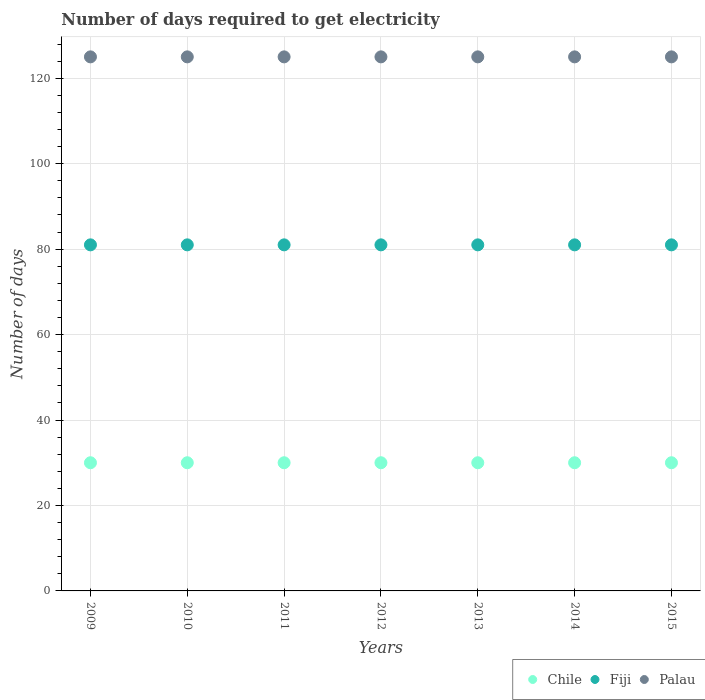Is the number of dotlines equal to the number of legend labels?
Make the answer very short. Yes. What is the number of days required to get electricity in in Palau in 2009?
Ensure brevity in your answer.  125. Across all years, what is the maximum number of days required to get electricity in in Chile?
Provide a succinct answer. 30. Across all years, what is the minimum number of days required to get electricity in in Chile?
Provide a succinct answer. 30. In which year was the number of days required to get electricity in in Fiji maximum?
Provide a succinct answer. 2009. In which year was the number of days required to get electricity in in Chile minimum?
Your answer should be compact. 2009. What is the total number of days required to get electricity in in Fiji in the graph?
Your answer should be very brief. 567. What is the difference between the number of days required to get electricity in in Fiji in 2013 and the number of days required to get electricity in in Chile in 2014?
Make the answer very short. 51. In the year 2015, what is the difference between the number of days required to get electricity in in Fiji and number of days required to get electricity in in Palau?
Ensure brevity in your answer.  -44. In how many years, is the number of days required to get electricity in in Fiji greater than 120 days?
Make the answer very short. 0. What is the ratio of the number of days required to get electricity in in Chile in 2011 to that in 2012?
Ensure brevity in your answer.  1. Is the number of days required to get electricity in in Chile in 2013 less than that in 2014?
Provide a short and direct response. No. Is the sum of the number of days required to get electricity in in Chile in 2011 and 2012 greater than the maximum number of days required to get electricity in in Fiji across all years?
Your response must be concise. No. Is it the case that in every year, the sum of the number of days required to get electricity in in Chile and number of days required to get electricity in in Palau  is greater than the number of days required to get electricity in in Fiji?
Give a very brief answer. Yes. Does the number of days required to get electricity in in Fiji monotonically increase over the years?
Make the answer very short. No. How many dotlines are there?
Make the answer very short. 3. What is the difference between two consecutive major ticks on the Y-axis?
Your response must be concise. 20. Are the values on the major ticks of Y-axis written in scientific E-notation?
Your answer should be compact. No. Does the graph contain any zero values?
Your answer should be compact. No. Does the graph contain grids?
Give a very brief answer. Yes. How are the legend labels stacked?
Provide a succinct answer. Horizontal. What is the title of the graph?
Keep it short and to the point. Number of days required to get electricity. What is the label or title of the Y-axis?
Offer a terse response. Number of days. What is the Number of days of Palau in 2009?
Keep it short and to the point. 125. What is the Number of days in Chile in 2010?
Your answer should be very brief. 30. What is the Number of days of Palau in 2010?
Give a very brief answer. 125. What is the Number of days of Palau in 2011?
Your response must be concise. 125. What is the Number of days in Chile in 2012?
Your answer should be compact. 30. What is the Number of days of Palau in 2012?
Offer a terse response. 125. What is the Number of days of Palau in 2013?
Provide a succinct answer. 125. What is the Number of days in Chile in 2014?
Offer a terse response. 30. What is the Number of days in Palau in 2014?
Your answer should be very brief. 125. What is the Number of days of Chile in 2015?
Keep it short and to the point. 30. What is the Number of days of Palau in 2015?
Your answer should be very brief. 125. Across all years, what is the maximum Number of days of Palau?
Provide a succinct answer. 125. Across all years, what is the minimum Number of days in Chile?
Offer a terse response. 30. Across all years, what is the minimum Number of days in Palau?
Make the answer very short. 125. What is the total Number of days in Chile in the graph?
Offer a very short reply. 210. What is the total Number of days in Fiji in the graph?
Provide a short and direct response. 567. What is the total Number of days in Palau in the graph?
Your answer should be compact. 875. What is the difference between the Number of days in Chile in 2009 and that in 2010?
Give a very brief answer. 0. What is the difference between the Number of days in Fiji in 2009 and that in 2010?
Your response must be concise. 0. What is the difference between the Number of days in Palau in 2009 and that in 2010?
Provide a short and direct response. 0. What is the difference between the Number of days in Chile in 2009 and that in 2011?
Offer a very short reply. 0. What is the difference between the Number of days in Palau in 2009 and that in 2011?
Make the answer very short. 0. What is the difference between the Number of days of Palau in 2009 and that in 2012?
Make the answer very short. 0. What is the difference between the Number of days in Fiji in 2009 and that in 2014?
Your answer should be very brief. 0. What is the difference between the Number of days in Palau in 2009 and that in 2014?
Give a very brief answer. 0. What is the difference between the Number of days of Fiji in 2009 and that in 2015?
Provide a succinct answer. 0. What is the difference between the Number of days of Palau in 2009 and that in 2015?
Your answer should be compact. 0. What is the difference between the Number of days in Fiji in 2010 and that in 2011?
Make the answer very short. 0. What is the difference between the Number of days of Fiji in 2010 and that in 2012?
Your response must be concise. 0. What is the difference between the Number of days of Chile in 2010 and that in 2013?
Ensure brevity in your answer.  0. What is the difference between the Number of days in Palau in 2010 and that in 2013?
Ensure brevity in your answer.  0. What is the difference between the Number of days in Chile in 2010 and that in 2014?
Provide a succinct answer. 0. What is the difference between the Number of days in Fiji in 2010 and that in 2014?
Give a very brief answer. 0. What is the difference between the Number of days of Palau in 2010 and that in 2014?
Make the answer very short. 0. What is the difference between the Number of days of Fiji in 2010 and that in 2015?
Provide a short and direct response. 0. What is the difference between the Number of days of Chile in 2011 and that in 2013?
Your answer should be very brief. 0. What is the difference between the Number of days in Fiji in 2011 and that in 2013?
Offer a very short reply. 0. What is the difference between the Number of days of Palau in 2011 and that in 2013?
Provide a short and direct response. 0. What is the difference between the Number of days in Chile in 2011 and that in 2014?
Provide a succinct answer. 0. What is the difference between the Number of days of Fiji in 2011 and that in 2014?
Provide a short and direct response. 0. What is the difference between the Number of days of Chile in 2011 and that in 2015?
Your answer should be very brief. 0. What is the difference between the Number of days of Palau in 2011 and that in 2015?
Your answer should be compact. 0. What is the difference between the Number of days in Chile in 2012 and that in 2013?
Make the answer very short. 0. What is the difference between the Number of days of Palau in 2012 and that in 2013?
Give a very brief answer. 0. What is the difference between the Number of days in Chile in 2012 and that in 2014?
Ensure brevity in your answer.  0. What is the difference between the Number of days in Palau in 2012 and that in 2014?
Keep it short and to the point. 0. What is the difference between the Number of days of Chile in 2012 and that in 2015?
Provide a succinct answer. 0. What is the difference between the Number of days of Fiji in 2012 and that in 2015?
Your response must be concise. 0. What is the difference between the Number of days in Palau in 2012 and that in 2015?
Provide a succinct answer. 0. What is the difference between the Number of days of Chile in 2013 and that in 2014?
Provide a short and direct response. 0. What is the difference between the Number of days of Palau in 2013 and that in 2015?
Keep it short and to the point. 0. What is the difference between the Number of days in Chile in 2014 and that in 2015?
Offer a very short reply. 0. What is the difference between the Number of days of Fiji in 2014 and that in 2015?
Offer a terse response. 0. What is the difference between the Number of days of Palau in 2014 and that in 2015?
Offer a very short reply. 0. What is the difference between the Number of days in Chile in 2009 and the Number of days in Fiji in 2010?
Keep it short and to the point. -51. What is the difference between the Number of days of Chile in 2009 and the Number of days of Palau in 2010?
Your response must be concise. -95. What is the difference between the Number of days of Fiji in 2009 and the Number of days of Palau in 2010?
Make the answer very short. -44. What is the difference between the Number of days of Chile in 2009 and the Number of days of Fiji in 2011?
Provide a succinct answer. -51. What is the difference between the Number of days in Chile in 2009 and the Number of days in Palau in 2011?
Ensure brevity in your answer.  -95. What is the difference between the Number of days of Fiji in 2009 and the Number of days of Palau in 2011?
Make the answer very short. -44. What is the difference between the Number of days of Chile in 2009 and the Number of days of Fiji in 2012?
Provide a short and direct response. -51. What is the difference between the Number of days of Chile in 2009 and the Number of days of Palau in 2012?
Offer a terse response. -95. What is the difference between the Number of days in Fiji in 2009 and the Number of days in Palau in 2012?
Ensure brevity in your answer.  -44. What is the difference between the Number of days in Chile in 2009 and the Number of days in Fiji in 2013?
Provide a succinct answer. -51. What is the difference between the Number of days of Chile in 2009 and the Number of days of Palau in 2013?
Make the answer very short. -95. What is the difference between the Number of days of Fiji in 2009 and the Number of days of Palau in 2013?
Ensure brevity in your answer.  -44. What is the difference between the Number of days in Chile in 2009 and the Number of days in Fiji in 2014?
Your response must be concise. -51. What is the difference between the Number of days in Chile in 2009 and the Number of days in Palau in 2014?
Offer a very short reply. -95. What is the difference between the Number of days in Fiji in 2009 and the Number of days in Palau in 2014?
Your answer should be very brief. -44. What is the difference between the Number of days in Chile in 2009 and the Number of days in Fiji in 2015?
Provide a succinct answer. -51. What is the difference between the Number of days in Chile in 2009 and the Number of days in Palau in 2015?
Your response must be concise. -95. What is the difference between the Number of days of Fiji in 2009 and the Number of days of Palau in 2015?
Offer a terse response. -44. What is the difference between the Number of days in Chile in 2010 and the Number of days in Fiji in 2011?
Your response must be concise. -51. What is the difference between the Number of days in Chile in 2010 and the Number of days in Palau in 2011?
Offer a terse response. -95. What is the difference between the Number of days of Fiji in 2010 and the Number of days of Palau in 2011?
Your response must be concise. -44. What is the difference between the Number of days in Chile in 2010 and the Number of days in Fiji in 2012?
Your response must be concise. -51. What is the difference between the Number of days in Chile in 2010 and the Number of days in Palau in 2012?
Keep it short and to the point. -95. What is the difference between the Number of days in Fiji in 2010 and the Number of days in Palau in 2012?
Keep it short and to the point. -44. What is the difference between the Number of days in Chile in 2010 and the Number of days in Fiji in 2013?
Keep it short and to the point. -51. What is the difference between the Number of days in Chile in 2010 and the Number of days in Palau in 2013?
Your response must be concise. -95. What is the difference between the Number of days in Fiji in 2010 and the Number of days in Palau in 2013?
Your response must be concise. -44. What is the difference between the Number of days in Chile in 2010 and the Number of days in Fiji in 2014?
Give a very brief answer. -51. What is the difference between the Number of days in Chile in 2010 and the Number of days in Palau in 2014?
Keep it short and to the point. -95. What is the difference between the Number of days of Fiji in 2010 and the Number of days of Palau in 2014?
Keep it short and to the point. -44. What is the difference between the Number of days in Chile in 2010 and the Number of days in Fiji in 2015?
Your answer should be compact. -51. What is the difference between the Number of days in Chile in 2010 and the Number of days in Palau in 2015?
Provide a succinct answer. -95. What is the difference between the Number of days of Fiji in 2010 and the Number of days of Palau in 2015?
Keep it short and to the point. -44. What is the difference between the Number of days of Chile in 2011 and the Number of days of Fiji in 2012?
Provide a short and direct response. -51. What is the difference between the Number of days of Chile in 2011 and the Number of days of Palau in 2012?
Offer a very short reply. -95. What is the difference between the Number of days in Fiji in 2011 and the Number of days in Palau in 2012?
Keep it short and to the point. -44. What is the difference between the Number of days in Chile in 2011 and the Number of days in Fiji in 2013?
Your answer should be very brief. -51. What is the difference between the Number of days in Chile in 2011 and the Number of days in Palau in 2013?
Ensure brevity in your answer.  -95. What is the difference between the Number of days of Fiji in 2011 and the Number of days of Palau in 2013?
Provide a succinct answer. -44. What is the difference between the Number of days of Chile in 2011 and the Number of days of Fiji in 2014?
Offer a terse response. -51. What is the difference between the Number of days in Chile in 2011 and the Number of days in Palau in 2014?
Make the answer very short. -95. What is the difference between the Number of days in Fiji in 2011 and the Number of days in Palau in 2014?
Make the answer very short. -44. What is the difference between the Number of days of Chile in 2011 and the Number of days of Fiji in 2015?
Keep it short and to the point. -51. What is the difference between the Number of days in Chile in 2011 and the Number of days in Palau in 2015?
Offer a terse response. -95. What is the difference between the Number of days in Fiji in 2011 and the Number of days in Palau in 2015?
Offer a terse response. -44. What is the difference between the Number of days in Chile in 2012 and the Number of days in Fiji in 2013?
Ensure brevity in your answer.  -51. What is the difference between the Number of days of Chile in 2012 and the Number of days of Palau in 2013?
Provide a succinct answer. -95. What is the difference between the Number of days in Fiji in 2012 and the Number of days in Palau in 2013?
Give a very brief answer. -44. What is the difference between the Number of days of Chile in 2012 and the Number of days of Fiji in 2014?
Your answer should be compact. -51. What is the difference between the Number of days in Chile in 2012 and the Number of days in Palau in 2014?
Give a very brief answer. -95. What is the difference between the Number of days of Fiji in 2012 and the Number of days of Palau in 2014?
Ensure brevity in your answer.  -44. What is the difference between the Number of days of Chile in 2012 and the Number of days of Fiji in 2015?
Ensure brevity in your answer.  -51. What is the difference between the Number of days of Chile in 2012 and the Number of days of Palau in 2015?
Make the answer very short. -95. What is the difference between the Number of days in Fiji in 2012 and the Number of days in Palau in 2015?
Your answer should be very brief. -44. What is the difference between the Number of days of Chile in 2013 and the Number of days of Fiji in 2014?
Your answer should be very brief. -51. What is the difference between the Number of days of Chile in 2013 and the Number of days of Palau in 2014?
Provide a succinct answer. -95. What is the difference between the Number of days of Fiji in 2013 and the Number of days of Palau in 2014?
Provide a succinct answer. -44. What is the difference between the Number of days in Chile in 2013 and the Number of days in Fiji in 2015?
Make the answer very short. -51. What is the difference between the Number of days of Chile in 2013 and the Number of days of Palau in 2015?
Provide a short and direct response. -95. What is the difference between the Number of days in Fiji in 2013 and the Number of days in Palau in 2015?
Your answer should be very brief. -44. What is the difference between the Number of days in Chile in 2014 and the Number of days in Fiji in 2015?
Give a very brief answer. -51. What is the difference between the Number of days in Chile in 2014 and the Number of days in Palau in 2015?
Offer a terse response. -95. What is the difference between the Number of days in Fiji in 2014 and the Number of days in Palau in 2015?
Give a very brief answer. -44. What is the average Number of days of Chile per year?
Offer a very short reply. 30. What is the average Number of days in Palau per year?
Keep it short and to the point. 125. In the year 2009, what is the difference between the Number of days of Chile and Number of days of Fiji?
Keep it short and to the point. -51. In the year 2009, what is the difference between the Number of days in Chile and Number of days in Palau?
Ensure brevity in your answer.  -95. In the year 2009, what is the difference between the Number of days in Fiji and Number of days in Palau?
Give a very brief answer. -44. In the year 2010, what is the difference between the Number of days of Chile and Number of days of Fiji?
Your response must be concise. -51. In the year 2010, what is the difference between the Number of days of Chile and Number of days of Palau?
Provide a short and direct response. -95. In the year 2010, what is the difference between the Number of days in Fiji and Number of days in Palau?
Your answer should be compact. -44. In the year 2011, what is the difference between the Number of days of Chile and Number of days of Fiji?
Your response must be concise. -51. In the year 2011, what is the difference between the Number of days in Chile and Number of days in Palau?
Ensure brevity in your answer.  -95. In the year 2011, what is the difference between the Number of days in Fiji and Number of days in Palau?
Provide a succinct answer. -44. In the year 2012, what is the difference between the Number of days in Chile and Number of days in Fiji?
Your answer should be very brief. -51. In the year 2012, what is the difference between the Number of days in Chile and Number of days in Palau?
Your response must be concise. -95. In the year 2012, what is the difference between the Number of days of Fiji and Number of days of Palau?
Give a very brief answer. -44. In the year 2013, what is the difference between the Number of days in Chile and Number of days in Fiji?
Your answer should be very brief. -51. In the year 2013, what is the difference between the Number of days of Chile and Number of days of Palau?
Your answer should be very brief. -95. In the year 2013, what is the difference between the Number of days of Fiji and Number of days of Palau?
Your response must be concise. -44. In the year 2014, what is the difference between the Number of days in Chile and Number of days in Fiji?
Make the answer very short. -51. In the year 2014, what is the difference between the Number of days in Chile and Number of days in Palau?
Keep it short and to the point. -95. In the year 2014, what is the difference between the Number of days in Fiji and Number of days in Palau?
Your response must be concise. -44. In the year 2015, what is the difference between the Number of days in Chile and Number of days in Fiji?
Provide a succinct answer. -51. In the year 2015, what is the difference between the Number of days in Chile and Number of days in Palau?
Ensure brevity in your answer.  -95. In the year 2015, what is the difference between the Number of days in Fiji and Number of days in Palau?
Your response must be concise. -44. What is the ratio of the Number of days in Fiji in 2009 to that in 2010?
Keep it short and to the point. 1. What is the ratio of the Number of days of Chile in 2009 to that in 2011?
Provide a succinct answer. 1. What is the ratio of the Number of days in Fiji in 2009 to that in 2011?
Your answer should be compact. 1. What is the ratio of the Number of days of Chile in 2009 to that in 2012?
Make the answer very short. 1. What is the ratio of the Number of days of Palau in 2009 to that in 2012?
Your answer should be very brief. 1. What is the ratio of the Number of days in Chile in 2009 to that in 2013?
Keep it short and to the point. 1. What is the ratio of the Number of days in Fiji in 2009 to that in 2014?
Ensure brevity in your answer.  1. What is the ratio of the Number of days in Palau in 2009 to that in 2014?
Your response must be concise. 1. What is the ratio of the Number of days in Chile in 2009 to that in 2015?
Provide a short and direct response. 1. What is the ratio of the Number of days in Fiji in 2009 to that in 2015?
Offer a very short reply. 1. What is the ratio of the Number of days of Palau in 2009 to that in 2015?
Provide a succinct answer. 1. What is the ratio of the Number of days of Chile in 2010 to that in 2011?
Provide a short and direct response. 1. What is the ratio of the Number of days of Fiji in 2010 to that in 2011?
Your response must be concise. 1. What is the ratio of the Number of days of Chile in 2010 to that in 2012?
Your response must be concise. 1. What is the ratio of the Number of days of Fiji in 2010 to that in 2012?
Your answer should be very brief. 1. What is the ratio of the Number of days of Fiji in 2010 to that in 2013?
Provide a succinct answer. 1. What is the ratio of the Number of days of Chile in 2010 to that in 2014?
Keep it short and to the point. 1. What is the ratio of the Number of days of Palau in 2010 to that in 2014?
Give a very brief answer. 1. What is the ratio of the Number of days of Palau in 2010 to that in 2015?
Provide a short and direct response. 1. What is the ratio of the Number of days of Chile in 2011 to that in 2012?
Give a very brief answer. 1. What is the ratio of the Number of days of Fiji in 2011 to that in 2012?
Offer a very short reply. 1. What is the ratio of the Number of days in Chile in 2011 to that in 2013?
Ensure brevity in your answer.  1. What is the ratio of the Number of days of Fiji in 2011 to that in 2013?
Offer a terse response. 1. What is the ratio of the Number of days in Chile in 2011 to that in 2014?
Ensure brevity in your answer.  1. What is the ratio of the Number of days in Chile in 2011 to that in 2015?
Provide a short and direct response. 1. What is the ratio of the Number of days of Palau in 2011 to that in 2015?
Keep it short and to the point. 1. What is the ratio of the Number of days in Chile in 2012 to that in 2013?
Your answer should be compact. 1. What is the ratio of the Number of days in Fiji in 2012 to that in 2013?
Offer a very short reply. 1. What is the ratio of the Number of days of Palau in 2012 to that in 2013?
Ensure brevity in your answer.  1. What is the ratio of the Number of days of Palau in 2012 to that in 2014?
Your answer should be compact. 1. What is the ratio of the Number of days of Chile in 2013 to that in 2015?
Your answer should be very brief. 1. What is the ratio of the Number of days of Chile in 2014 to that in 2015?
Offer a terse response. 1. What is the ratio of the Number of days in Fiji in 2014 to that in 2015?
Offer a terse response. 1. What is the ratio of the Number of days of Palau in 2014 to that in 2015?
Offer a very short reply. 1. What is the difference between the highest and the second highest Number of days of Chile?
Provide a short and direct response. 0. What is the difference between the highest and the second highest Number of days of Fiji?
Your answer should be very brief. 0. What is the difference between the highest and the lowest Number of days in Chile?
Make the answer very short. 0. What is the difference between the highest and the lowest Number of days of Fiji?
Offer a terse response. 0. 